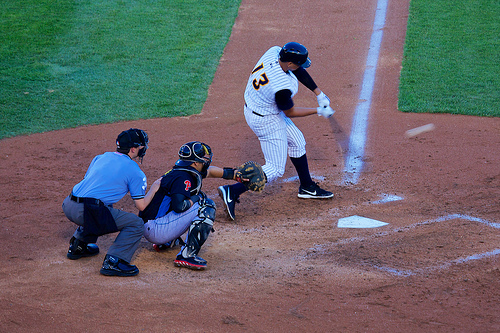Who is wearing a glove? The catcher, positioned behind the batter, is the one wearing the glove, crucial for his defensive role in the game. 